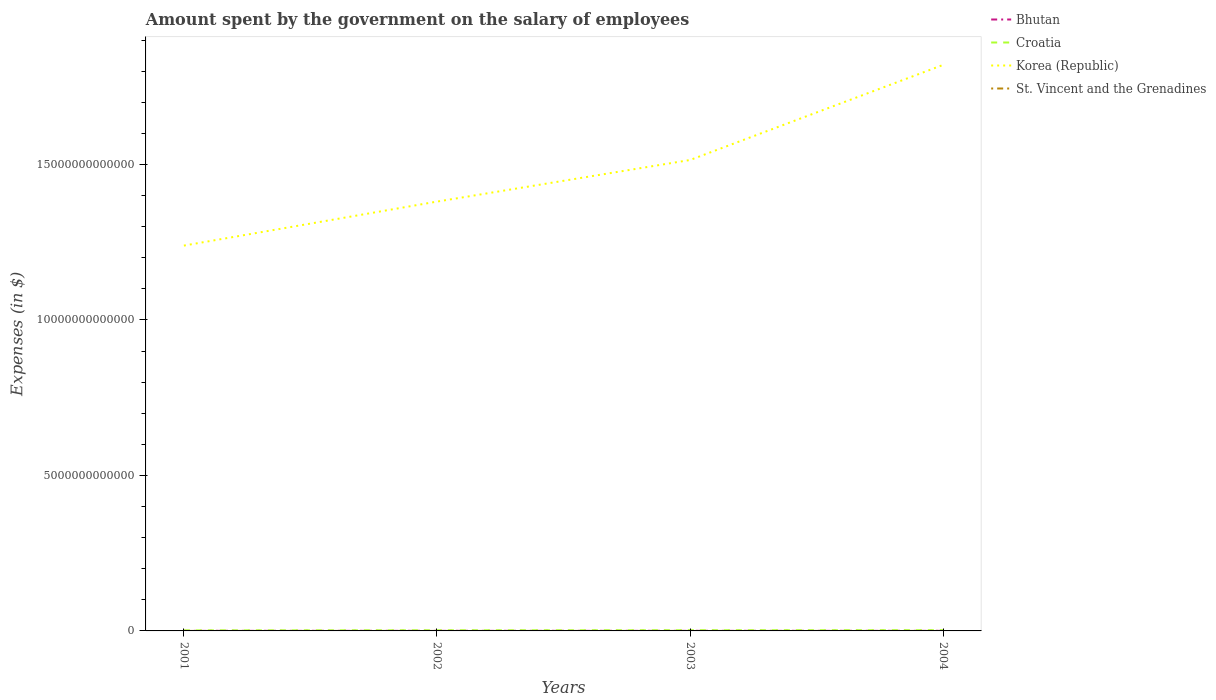How many different coloured lines are there?
Your response must be concise. 4. Across all years, what is the maximum amount spent on the salary of employees by the government in St. Vincent and the Grenadines?
Give a very brief answer. 1.29e+08. What is the total amount spent on the salary of employees by the government in Bhutan in the graph?
Ensure brevity in your answer.  -1.40e+08. What is the difference between the highest and the second highest amount spent on the salary of employees by the government in Croatia?
Provide a succinct answer. 5.64e+09. What is the difference between the highest and the lowest amount spent on the salary of employees by the government in Croatia?
Ensure brevity in your answer.  2. What is the difference between two consecutive major ticks on the Y-axis?
Your response must be concise. 5.00e+12. Are the values on the major ticks of Y-axis written in scientific E-notation?
Your answer should be very brief. No. How are the legend labels stacked?
Give a very brief answer. Vertical. What is the title of the graph?
Give a very brief answer. Amount spent by the government on the salary of employees. Does "Antigua and Barbuda" appear as one of the legend labels in the graph?
Offer a terse response. No. What is the label or title of the X-axis?
Make the answer very short. Years. What is the label or title of the Y-axis?
Your answer should be compact. Expenses (in $). What is the Expenses (in $) of Bhutan in 2001?
Provide a succinct answer. 1.72e+09. What is the Expenses (in $) in Croatia in 2001?
Provide a short and direct response. 1.76e+1. What is the Expenses (in $) in Korea (Republic) in 2001?
Ensure brevity in your answer.  1.24e+13. What is the Expenses (in $) of St. Vincent and the Grenadines in 2001?
Keep it short and to the point. 1.29e+08. What is the Expenses (in $) in Bhutan in 2002?
Your response must be concise. 1.90e+09. What is the Expenses (in $) of Croatia in 2002?
Provide a short and direct response. 2.03e+1. What is the Expenses (in $) of Korea (Republic) in 2002?
Provide a succinct answer. 1.38e+13. What is the Expenses (in $) of St. Vincent and the Grenadines in 2002?
Ensure brevity in your answer.  1.38e+08. What is the Expenses (in $) of Bhutan in 2003?
Offer a terse response. 1.95e+09. What is the Expenses (in $) of Croatia in 2003?
Your answer should be very brief. 2.21e+1. What is the Expenses (in $) of Korea (Republic) in 2003?
Your response must be concise. 1.51e+13. What is the Expenses (in $) of St. Vincent and the Grenadines in 2003?
Provide a succinct answer. 1.39e+08. What is the Expenses (in $) in Bhutan in 2004?
Keep it short and to the point. 2.09e+09. What is the Expenses (in $) of Croatia in 2004?
Provide a short and direct response. 2.33e+1. What is the Expenses (in $) of Korea (Republic) in 2004?
Your response must be concise. 1.82e+13. What is the Expenses (in $) of St. Vincent and the Grenadines in 2004?
Ensure brevity in your answer.  1.45e+08. Across all years, what is the maximum Expenses (in $) of Bhutan?
Your answer should be very brief. 2.09e+09. Across all years, what is the maximum Expenses (in $) of Croatia?
Offer a very short reply. 2.33e+1. Across all years, what is the maximum Expenses (in $) of Korea (Republic)?
Provide a short and direct response. 1.82e+13. Across all years, what is the maximum Expenses (in $) in St. Vincent and the Grenadines?
Your answer should be compact. 1.45e+08. Across all years, what is the minimum Expenses (in $) of Bhutan?
Provide a short and direct response. 1.72e+09. Across all years, what is the minimum Expenses (in $) in Croatia?
Make the answer very short. 1.76e+1. Across all years, what is the minimum Expenses (in $) of Korea (Republic)?
Your answer should be compact. 1.24e+13. Across all years, what is the minimum Expenses (in $) in St. Vincent and the Grenadines?
Make the answer very short. 1.29e+08. What is the total Expenses (in $) of Bhutan in the graph?
Ensure brevity in your answer.  7.65e+09. What is the total Expenses (in $) in Croatia in the graph?
Keep it short and to the point. 8.33e+1. What is the total Expenses (in $) of Korea (Republic) in the graph?
Your response must be concise. 5.96e+13. What is the total Expenses (in $) of St. Vincent and the Grenadines in the graph?
Keep it short and to the point. 5.51e+08. What is the difference between the Expenses (in $) of Bhutan in 2001 and that in 2002?
Give a very brief answer. -1.74e+08. What is the difference between the Expenses (in $) of Croatia in 2001 and that in 2002?
Offer a terse response. -2.66e+09. What is the difference between the Expenses (in $) in Korea (Republic) in 2001 and that in 2002?
Your response must be concise. -1.41e+12. What is the difference between the Expenses (in $) in St. Vincent and the Grenadines in 2001 and that in 2002?
Offer a very short reply. -9.70e+06. What is the difference between the Expenses (in $) in Bhutan in 2001 and that in 2003?
Ensure brevity in your answer.  -2.24e+08. What is the difference between the Expenses (in $) in Croatia in 2001 and that in 2003?
Your response must be concise. -4.44e+09. What is the difference between the Expenses (in $) of Korea (Republic) in 2001 and that in 2003?
Your answer should be very brief. -2.75e+12. What is the difference between the Expenses (in $) in St. Vincent and the Grenadines in 2001 and that in 2003?
Ensure brevity in your answer.  -1.05e+07. What is the difference between the Expenses (in $) in Bhutan in 2001 and that in 2004?
Offer a terse response. -3.64e+08. What is the difference between the Expenses (in $) of Croatia in 2001 and that in 2004?
Offer a very short reply. -5.64e+09. What is the difference between the Expenses (in $) in Korea (Republic) in 2001 and that in 2004?
Offer a very short reply. -5.81e+12. What is the difference between the Expenses (in $) in St. Vincent and the Grenadines in 2001 and that in 2004?
Your response must be concise. -1.62e+07. What is the difference between the Expenses (in $) in Bhutan in 2002 and that in 2003?
Offer a very short reply. -4.99e+07. What is the difference between the Expenses (in $) of Croatia in 2002 and that in 2003?
Your answer should be compact. -1.78e+09. What is the difference between the Expenses (in $) of Korea (Republic) in 2002 and that in 2003?
Offer a terse response. -1.34e+12. What is the difference between the Expenses (in $) of St. Vincent and the Grenadines in 2002 and that in 2003?
Offer a very short reply. -8.00e+05. What is the difference between the Expenses (in $) in Bhutan in 2002 and that in 2004?
Provide a short and direct response. -1.90e+08. What is the difference between the Expenses (in $) in Croatia in 2002 and that in 2004?
Your answer should be very brief. -2.98e+09. What is the difference between the Expenses (in $) of Korea (Republic) in 2002 and that in 2004?
Provide a succinct answer. -4.40e+12. What is the difference between the Expenses (in $) of St. Vincent and the Grenadines in 2002 and that in 2004?
Make the answer very short. -6.50e+06. What is the difference between the Expenses (in $) in Bhutan in 2003 and that in 2004?
Ensure brevity in your answer.  -1.40e+08. What is the difference between the Expenses (in $) in Croatia in 2003 and that in 2004?
Give a very brief answer. -1.20e+09. What is the difference between the Expenses (in $) in Korea (Republic) in 2003 and that in 2004?
Your answer should be compact. -3.06e+12. What is the difference between the Expenses (in $) in St. Vincent and the Grenadines in 2003 and that in 2004?
Ensure brevity in your answer.  -5.70e+06. What is the difference between the Expenses (in $) of Bhutan in 2001 and the Expenses (in $) of Croatia in 2002?
Provide a succinct answer. -1.86e+1. What is the difference between the Expenses (in $) in Bhutan in 2001 and the Expenses (in $) in Korea (Republic) in 2002?
Provide a short and direct response. -1.38e+13. What is the difference between the Expenses (in $) in Bhutan in 2001 and the Expenses (in $) in St. Vincent and the Grenadines in 2002?
Ensure brevity in your answer.  1.58e+09. What is the difference between the Expenses (in $) in Croatia in 2001 and the Expenses (in $) in Korea (Republic) in 2002?
Give a very brief answer. -1.38e+13. What is the difference between the Expenses (in $) in Croatia in 2001 and the Expenses (in $) in St. Vincent and the Grenadines in 2002?
Provide a short and direct response. 1.75e+1. What is the difference between the Expenses (in $) of Korea (Republic) in 2001 and the Expenses (in $) of St. Vincent and the Grenadines in 2002?
Ensure brevity in your answer.  1.24e+13. What is the difference between the Expenses (in $) in Bhutan in 2001 and the Expenses (in $) in Croatia in 2003?
Provide a succinct answer. -2.03e+1. What is the difference between the Expenses (in $) in Bhutan in 2001 and the Expenses (in $) in Korea (Republic) in 2003?
Provide a succinct answer. -1.51e+13. What is the difference between the Expenses (in $) in Bhutan in 2001 and the Expenses (in $) in St. Vincent and the Grenadines in 2003?
Your response must be concise. 1.58e+09. What is the difference between the Expenses (in $) in Croatia in 2001 and the Expenses (in $) in Korea (Republic) in 2003?
Provide a short and direct response. -1.51e+13. What is the difference between the Expenses (in $) of Croatia in 2001 and the Expenses (in $) of St. Vincent and the Grenadines in 2003?
Offer a very short reply. 1.75e+1. What is the difference between the Expenses (in $) of Korea (Republic) in 2001 and the Expenses (in $) of St. Vincent and the Grenadines in 2003?
Your response must be concise. 1.24e+13. What is the difference between the Expenses (in $) in Bhutan in 2001 and the Expenses (in $) in Croatia in 2004?
Keep it short and to the point. -2.15e+1. What is the difference between the Expenses (in $) of Bhutan in 2001 and the Expenses (in $) of Korea (Republic) in 2004?
Offer a terse response. -1.82e+13. What is the difference between the Expenses (in $) of Bhutan in 2001 and the Expenses (in $) of St. Vincent and the Grenadines in 2004?
Ensure brevity in your answer.  1.58e+09. What is the difference between the Expenses (in $) in Croatia in 2001 and the Expenses (in $) in Korea (Republic) in 2004?
Your answer should be very brief. -1.82e+13. What is the difference between the Expenses (in $) in Croatia in 2001 and the Expenses (in $) in St. Vincent and the Grenadines in 2004?
Offer a very short reply. 1.75e+1. What is the difference between the Expenses (in $) of Korea (Republic) in 2001 and the Expenses (in $) of St. Vincent and the Grenadines in 2004?
Ensure brevity in your answer.  1.24e+13. What is the difference between the Expenses (in $) of Bhutan in 2002 and the Expenses (in $) of Croatia in 2003?
Keep it short and to the point. -2.02e+1. What is the difference between the Expenses (in $) of Bhutan in 2002 and the Expenses (in $) of Korea (Republic) in 2003?
Make the answer very short. -1.51e+13. What is the difference between the Expenses (in $) of Bhutan in 2002 and the Expenses (in $) of St. Vincent and the Grenadines in 2003?
Offer a very short reply. 1.76e+09. What is the difference between the Expenses (in $) in Croatia in 2002 and the Expenses (in $) in Korea (Republic) in 2003?
Your response must be concise. -1.51e+13. What is the difference between the Expenses (in $) in Croatia in 2002 and the Expenses (in $) in St. Vincent and the Grenadines in 2003?
Provide a short and direct response. 2.01e+1. What is the difference between the Expenses (in $) in Korea (Republic) in 2002 and the Expenses (in $) in St. Vincent and the Grenadines in 2003?
Offer a terse response. 1.38e+13. What is the difference between the Expenses (in $) in Bhutan in 2002 and the Expenses (in $) in Croatia in 2004?
Your answer should be compact. -2.14e+1. What is the difference between the Expenses (in $) of Bhutan in 2002 and the Expenses (in $) of Korea (Republic) in 2004?
Your answer should be compact. -1.82e+13. What is the difference between the Expenses (in $) of Bhutan in 2002 and the Expenses (in $) of St. Vincent and the Grenadines in 2004?
Provide a succinct answer. 1.75e+09. What is the difference between the Expenses (in $) of Croatia in 2002 and the Expenses (in $) of Korea (Republic) in 2004?
Your answer should be very brief. -1.82e+13. What is the difference between the Expenses (in $) of Croatia in 2002 and the Expenses (in $) of St. Vincent and the Grenadines in 2004?
Make the answer very short. 2.01e+1. What is the difference between the Expenses (in $) of Korea (Republic) in 2002 and the Expenses (in $) of St. Vincent and the Grenadines in 2004?
Offer a terse response. 1.38e+13. What is the difference between the Expenses (in $) of Bhutan in 2003 and the Expenses (in $) of Croatia in 2004?
Your answer should be compact. -2.13e+1. What is the difference between the Expenses (in $) of Bhutan in 2003 and the Expenses (in $) of Korea (Republic) in 2004?
Your answer should be very brief. -1.82e+13. What is the difference between the Expenses (in $) in Bhutan in 2003 and the Expenses (in $) in St. Vincent and the Grenadines in 2004?
Offer a terse response. 1.80e+09. What is the difference between the Expenses (in $) of Croatia in 2003 and the Expenses (in $) of Korea (Republic) in 2004?
Offer a very short reply. -1.82e+13. What is the difference between the Expenses (in $) of Croatia in 2003 and the Expenses (in $) of St. Vincent and the Grenadines in 2004?
Offer a very short reply. 2.19e+1. What is the difference between the Expenses (in $) in Korea (Republic) in 2003 and the Expenses (in $) in St. Vincent and the Grenadines in 2004?
Make the answer very short. 1.51e+13. What is the average Expenses (in $) in Bhutan per year?
Offer a terse response. 1.91e+09. What is the average Expenses (in $) of Croatia per year?
Your answer should be compact. 2.08e+1. What is the average Expenses (in $) of Korea (Republic) per year?
Offer a terse response. 1.49e+13. What is the average Expenses (in $) of St. Vincent and the Grenadines per year?
Your answer should be compact. 1.38e+08. In the year 2001, what is the difference between the Expenses (in $) in Bhutan and Expenses (in $) in Croatia?
Provide a short and direct response. -1.59e+1. In the year 2001, what is the difference between the Expenses (in $) in Bhutan and Expenses (in $) in Korea (Republic)?
Offer a very short reply. -1.24e+13. In the year 2001, what is the difference between the Expenses (in $) of Bhutan and Expenses (in $) of St. Vincent and the Grenadines?
Offer a very short reply. 1.59e+09. In the year 2001, what is the difference between the Expenses (in $) in Croatia and Expenses (in $) in Korea (Republic)?
Your answer should be compact. -1.24e+13. In the year 2001, what is the difference between the Expenses (in $) of Croatia and Expenses (in $) of St. Vincent and the Grenadines?
Your answer should be very brief. 1.75e+1. In the year 2001, what is the difference between the Expenses (in $) in Korea (Republic) and Expenses (in $) in St. Vincent and the Grenadines?
Your response must be concise. 1.24e+13. In the year 2002, what is the difference between the Expenses (in $) in Bhutan and Expenses (in $) in Croatia?
Your answer should be very brief. -1.84e+1. In the year 2002, what is the difference between the Expenses (in $) of Bhutan and Expenses (in $) of Korea (Republic)?
Give a very brief answer. -1.38e+13. In the year 2002, what is the difference between the Expenses (in $) in Bhutan and Expenses (in $) in St. Vincent and the Grenadines?
Keep it short and to the point. 1.76e+09. In the year 2002, what is the difference between the Expenses (in $) of Croatia and Expenses (in $) of Korea (Republic)?
Your answer should be compact. -1.38e+13. In the year 2002, what is the difference between the Expenses (in $) in Croatia and Expenses (in $) in St. Vincent and the Grenadines?
Your answer should be very brief. 2.01e+1. In the year 2002, what is the difference between the Expenses (in $) in Korea (Republic) and Expenses (in $) in St. Vincent and the Grenadines?
Your answer should be very brief. 1.38e+13. In the year 2003, what is the difference between the Expenses (in $) of Bhutan and Expenses (in $) of Croatia?
Your response must be concise. -2.01e+1. In the year 2003, what is the difference between the Expenses (in $) of Bhutan and Expenses (in $) of Korea (Republic)?
Your answer should be compact. -1.51e+13. In the year 2003, what is the difference between the Expenses (in $) of Bhutan and Expenses (in $) of St. Vincent and the Grenadines?
Make the answer very short. 1.81e+09. In the year 2003, what is the difference between the Expenses (in $) in Croatia and Expenses (in $) in Korea (Republic)?
Make the answer very short. -1.51e+13. In the year 2003, what is the difference between the Expenses (in $) of Croatia and Expenses (in $) of St. Vincent and the Grenadines?
Your answer should be compact. 2.19e+1. In the year 2003, what is the difference between the Expenses (in $) in Korea (Republic) and Expenses (in $) in St. Vincent and the Grenadines?
Ensure brevity in your answer.  1.51e+13. In the year 2004, what is the difference between the Expenses (in $) in Bhutan and Expenses (in $) in Croatia?
Keep it short and to the point. -2.12e+1. In the year 2004, what is the difference between the Expenses (in $) in Bhutan and Expenses (in $) in Korea (Republic)?
Offer a terse response. -1.82e+13. In the year 2004, what is the difference between the Expenses (in $) of Bhutan and Expenses (in $) of St. Vincent and the Grenadines?
Your answer should be compact. 1.94e+09. In the year 2004, what is the difference between the Expenses (in $) in Croatia and Expenses (in $) in Korea (Republic)?
Keep it short and to the point. -1.82e+13. In the year 2004, what is the difference between the Expenses (in $) in Croatia and Expenses (in $) in St. Vincent and the Grenadines?
Give a very brief answer. 2.31e+1. In the year 2004, what is the difference between the Expenses (in $) of Korea (Republic) and Expenses (in $) of St. Vincent and the Grenadines?
Provide a succinct answer. 1.82e+13. What is the ratio of the Expenses (in $) in Bhutan in 2001 to that in 2002?
Make the answer very short. 0.91. What is the ratio of the Expenses (in $) in Croatia in 2001 to that in 2002?
Provide a short and direct response. 0.87. What is the ratio of the Expenses (in $) of Korea (Republic) in 2001 to that in 2002?
Your response must be concise. 0.9. What is the ratio of the Expenses (in $) of St. Vincent and the Grenadines in 2001 to that in 2002?
Make the answer very short. 0.93. What is the ratio of the Expenses (in $) in Bhutan in 2001 to that in 2003?
Keep it short and to the point. 0.88. What is the ratio of the Expenses (in $) in Croatia in 2001 to that in 2003?
Offer a very short reply. 0.8. What is the ratio of the Expenses (in $) in Korea (Republic) in 2001 to that in 2003?
Offer a terse response. 0.82. What is the ratio of the Expenses (in $) in St. Vincent and the Grenadines in 2001 to that in 2003?
Your answer should be compact. 0.92. What is the ratio of the Expenses (in $) of Bhutan in 2001 to that in 2004?
Your answer should be very brief. 0.83. What is the ratio of the Expenses (in $) in Croatia in 2001 to that in 2004?
Provide a succinct answer. 0.76. What is the ratio of the Expenses (in $) of Korea (Republic) in 2001 to that in 2004?
Ensure brevity in your answer.  0.68. What is the ratio of the Expenses (in $) in St. Vincent and the Grenadines in 2001 to that in 2004?
Keep it short and to the point. 0.89. What is the ratio of the Expenses (in $) in Bhutan in 2002 to that in 2003?
Offer a terse response. 0.97. What is the ratio of the Expenses (in $) in Croatia in 2002 to that in 2003?
Your response must be concise. 0.92. What is the ratio of the Expenses (in $) of Korea (Republic) in 2002 to that in 2003?
Give a very brief answer. 0.91. What is the ratio of the Expenses (in $) in Croatia in 2002 to that in 2004?
Your response must be concise. 0.87. What is the ratio of the Expenses (in $) of Korea (Republic) in 2002 to that in 2004?
Offer a very short reply. 0.76. What is the ratio of the Expenses (in $) of St. Vincent and the Grenadines in 2002 to that in 2004?
Make the answer very short. 0.96. What is the ratio of the Expenses (in $) in Bhutan in 2003 to that in 2004?
Keep it short and to the point. 0.93. What is the ratio of the Expenses (in $) in Croatia in 2003 to that in 2004?
Offer a very short reply. 0.95. What is the ratio of the Expenses (in $) of Korea (Republic) in 2003 to that in 2004?
Ensure brevity in your answer.  0.83. What is the ratio of the Expenses (in $) of St. Vincent and the Grenadines in 2003 to that in 2004?
Make the answer very short. 0.96. What is the difference between the highest and the second highest Expenses (in $) in Bhutan?
Give a very brief answer. 1.40e+08. What is the difference between the highest and the second highest Expenses (in $) of Croatia?
Provide a short and direct response. 1.20e+09. What is the difference between the highest and the second highest Expenses (in $) in Korea (Republic)?
Offer a terse response. 3.06e+12. What is the difference between the highest and the second highest Expenses (in $) in St. Vincent and the Grenadines?
Provide a succinct answer. 5.70e+06. What is the difference between the highest and the lowest Expenses (in $) in Bhutan?
Your answer should be compact. 3.64e+08. What is the difference between the highest and the lowest Expenses (in $) in Croatia?
Ensure brevity in your answer.  5.64e+09. What is the difference between the highest and the lowest Expenses (in $) in Korea (Republic)?
Give a very brief answer. 5.81e+12. What is the difference between the highest and the lowest Expenses (in $) in St. Vincent and the Grenadines?
Make the answer very short. 1.62e+07. 